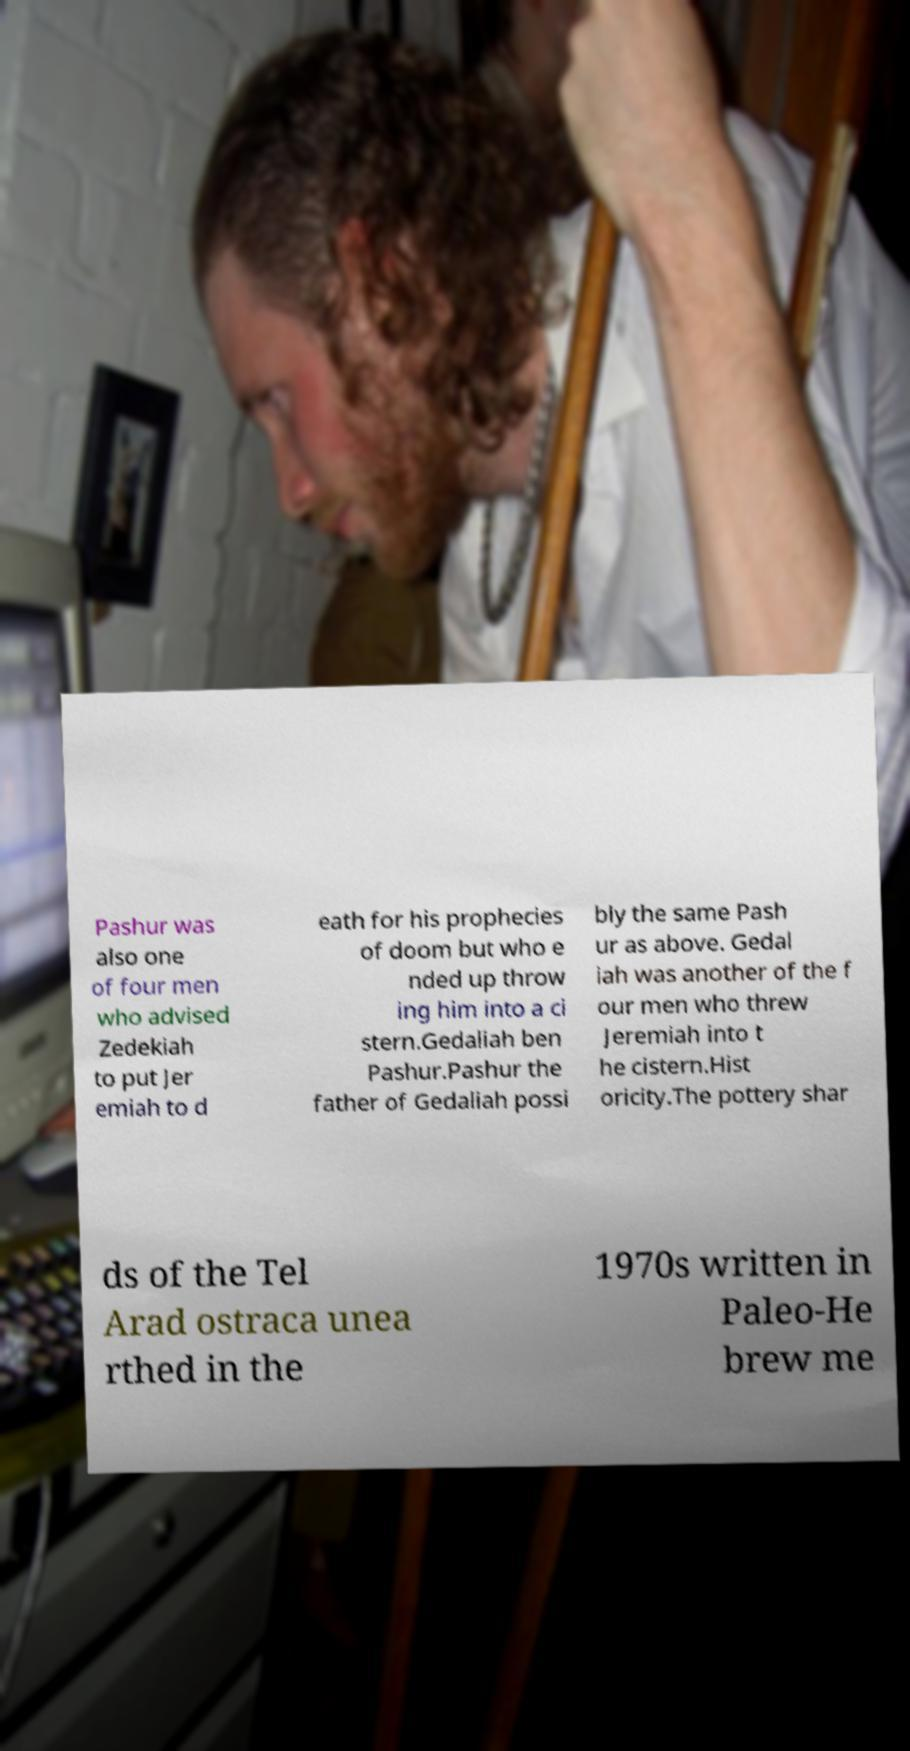What messages or text are displayed in this image? I need them in a readable, typed format. Pashur was also one of four men who advised Zedekiah to put Jer emiah to d eath for his prophecies of doom but who e nded up throw ing him into a ci stern.Gedaliah ben Pashur.Pashur the father of Gedaliah possi bly the same Pash ur as above. Gedal iah was another of the f our men who threw Jeremiah into t he cistern.Hist oricity.The pottery shar ds of the Tel Arad ostraca unea rthed in the 1970s written in Paleo-He brew me 